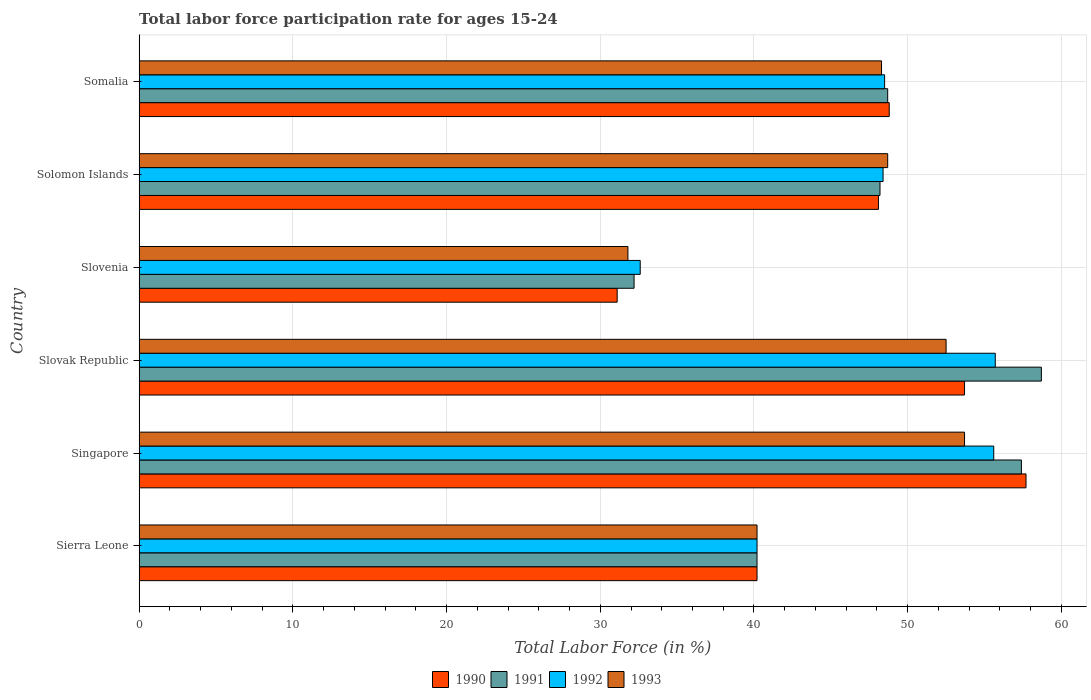How many groups of bars are there?
Your answer should be compact. 6. Are the number of bars per tick equal to the number of legend labels?
Make the answer very short. Yes. How many bars are there on the 3rd tick from the top?
Offer a very short reply. 4. What is the label of the 1st group of bars from the top?
Provide a short and direct response. Somalia. What is the labor force participation rate in 1991 in Sierra Leone?
Your answer should be very brief. 40.2. Across all countries, what is the maximum labor force participation rate in 1993?
Offer a terse response. 53.7. Across all countries, what is the minimum labor force participation rate in 1992?
Make the answer very short. 32.6. In which country was the labor force participation rate in 1991 maximum?
Offer a terse response. Slovak Republic. In which country was the labor force participation rate in 1990 minimum?
Offer a very short reply. Slovenia. What is the total labor force participation rate in 1991 in the graph?
Make the answer very short. 285.4. What is the difference between the labor force participation rate in 1991 in Slovenia and that in Somalia?
Your answer should be very brief. -16.5. What is the difference between the labor force participation rate in 1991 in Somalia and the labor force participation rate in 1990 in Solomon Islands?
Make the answer very short. 0.6. What is the average labor force participation rate in 1992 per country?
Your response must be concise. 46.83. In how many countries, is the labor force participation rate in 1993 greater than 18 %?
Ensure brevity in your answer.  6. What is the ratio of the labor force participation rate in 1991 in Sierra Leone to that in Slovak Republic?
Your answer should be compact. 0.68. Is the labor force participation rate in 1990 in Singapore less than that in Solomon Islands?
Make the answer very short. No. Is the difference between the labor force participation rate in 1992 in Singapore and Slovak Republic greater than the difference between the labor force participation rate in 1990 in Singapore and Slovak Republic?
Your response must be concise. No. What is the difference between the highest and the second highest labor force participation rate in 1993?
Your response must be concise. 1.2. What is the difference between the highest and the lowest labor force participation rate in 1993?
Give a very brief answer. 21.9. How many bars are there?
Keep it short and to the point. 24. Are all the bars in the graph horizontal?
Your answer should be very brief. Yes. How many countries are there in the graph?
Offer a very short reply. 6. Are the values on the major ticks of X-axis written in scientific E-notation?
Your response must be concise. No. Does the graph contain grids?
Offer a very short reply. Yes. How many legend labels are there?
Your answer should be very brief. 4. How are the legend labels stacked?
Your answer should be very brief. Horizontal. What is the title of the graph?
Keep it short and to the point. Total labor force participation rate for ages 15-24. What is the label or title of the X-axis?
Provide a short and direct response. Total Labor Force (in %). What is the label or title of the Y-axis?
Provide a succinct answer. Country. What is the Total Labor Force (in %) of 1990 in Sierra Leone?
Offer a very short reply. 40.2. What is the Total Labor Force (in %) in 1991 in Sierra Leone?
Provide a succinct answer. 40.2. What is the Total Labor Force (in %) in 1992 in Sierra Leone?
Make the answer very short. 40.2. What is the Total Labor Force (in %) of 1993 in Sierra Leone?
Offer a terse response. 40.2. What is the Total Labor Force (in %) in 1990 in Singapore?
Keep it short and to the point. 57.7. What is the Total Labor Force (in %) in 1991 in Singapore?
Offer a terse response. 57.4. What is the Total Labor Force (in %) in 1992 in Singapore?
Give a very brief answer. 55.6. What is the Total Labor Force (in %) in 1993 in Singapore?
Your answer should be compact. 53.7. What is the Total Labor Force (in %) in 1990 in Slovak Republic?
Offer a terse response. 53.7. What is the Total Labor Force (in %) in 1991 in Slovak Republic?
Offer a very short reply. 58.7. What is the Total Labor Force (in %) of 1992 in Slovak Republic?
Your answer should be compact. 55.7. What is the Total Labor Force (in %) in 1993 in Slovak Republic?
Ensure brevity in your answer.  52.5. What is the Total Labor Force (in %) in 1990 in Slovenia?
Your answer should be very brief. 31.1. What is the Total Labor Force (in %) of 1991 in Slovenia?
Provide a short and direct response. 32.2. What is the Total Labor Force (in %) in 1992 in Slovenia?
Your response must be concise. 32.6. What is the Total Labor Force (in %) in 1993 in Slovenia?
Provide a short and direct response. 31.8. What is the Total Labor Force (in %) of 1990 in Solomon Islands?
Keep it short and to the point. 48.1. What is the Total Labor Force (in %) in 1991 in Solomon Islands?
Your answer should be very brief. 48.2. What is the Total Labor Force (in %) of 1992 in Solomon Islands?
Your answer should be very brief. 48.4. What is the Total Labor Force (in %) in 1993 in Solomon Islands?
Ensure brevity in your answer.  48.7. What is the Total Labor Force (in %) in 1990 in Somalia?
Your response must be concise. 48.8. What is the Total Labor Force (in %) of 1991 in Somalia?
Your answer should be very brief. 48.7. What is the Total Labor Force (in %) in 1992 in Somalia?
Provide a succinct answer. 48.5. What is the Total Labor Force (in %) of 1993 in Somalia?
Your response must be concise. 48.3. Across all countries, what is the maximum Total Labor Force (in %) of 1990?
Your answer should be very brief. 57.7. Across all countries, what is the maximum Total Labor Force (in %) in 1991?
Offer a terse response. 58.7. Across all countries, what is the maximum Total Labor Force (in %) in 1992?
Your answer should be very brief. 55.7. Across all countries, what is the maximum Total Labor Force (in %) in 1993?
Offer a very short reply. 53.7. Across all countries, what is the minimum Total Labor Force (in %) of 1990?
Offer a terse response. 31.1. Across all countries, what is the minimum Total Labor Force (in %) in 1991?
Make the answer very short. 32.2. Across all countries, what is the minimum Total Labor Force (in %) of 1992?
Your answer should be very brief. 32.6. Across all countries, what is the minimum Total Labor Force (in %) in 1993?
Keep it short and to the point. 31.8. What is the total Total Labor Force (in %) in 1990 in the graph?
Provide a succinct answer. 279.6. What is the total Total Labor Force (in %) in 1991 in the graph?
Offer a terse response. 285.4. What is the total Total Labor Force (in %) in 1992 in the graph?
Offer a terse response. 281. What is the total Total Labor Force (in %) in 1993 in the graph?
Your answer should be compact. 275.2. What is the difference between the Total Labor Force (in %) of 1990 in Sierra Leone and that in Singapore?
Give a very brief answer. -17.5. What is the difference between the Total Labor Force (in %) in 1991 in Sierra Leone and that in Singapore?
Your answer should be very brief. -17.2. What is the difference between the Total Labor Force (in %) in 1992 in Sierra Leone and that in Singapore?
Your response must be concise. -15.4. What is the difference between the Total Labor Force (in %) of 1993 in Sierra Leone and that in Singapore?
Provide a short and direct response. -13.5. What is the difference between the Total Labor Force (in %) of 1991 in Sierra Leone and that in Slovak Republic?
Provide a succinct answer. -18.5. What is the difference between the Total Labor Force (in %) in 1992 in Sierra Leone and that in Slovak Republic?
Ensure brevity in your answer.  -15.5. What is the difference between the Total Labor Force (in %) in 1993 in Sierra Leone and that in Slovak Republic?
Keep it short and to the point. -12.3. What is the difference between the Total Labor Force (in %) of 1991 in Sierra Leone and that in Slovenia?
Your answer should be compact. 8. What is the difference between the Total Labor Force (in %) in 1992 in Sierra Leone and that in Slovenia?
Your response must be concise. 7.6. What is the difference between the Total Labor Force (in %) of 1993 in Sierra Leone and that in Slovenia?
Your answer should be compact. 8.4. What is the difference between the Total Labor Force (in %) of 1990 in Sierra Leone and that in Solomon Islands?
Your answer should be very brief. -7.9. What is the difference between the Total Labor Force (in %) in 1991 in Sierra Leone and that in Solomon Islands?
Ensure brevity in your answer.  -8. What is the difference between the Total Labor Force (in %) in 1993 in Sierra Leone and that in Solomon Islands?
Give a very brief answer. -8.5. What is the difference between the Total Labor Force (in %) in 1990 in Sierra Leone and that in Somalia?
Offer a very short reply. -8.6. What is the difference between the Total Labor Force (in %) in 1992 in Sierra Leone and that in Somalia?
Provide a succinct answer. -8.3. What is the difference between the Total Labor Force (in %) of 1993 in Sierra Leone and that in Somalia?
Give a very brief answer. -8.1. What is the difference between the Total Labor Force (in %) of 1990 in Singapore and that in Slovak Republic?
Keep it short and to the point. 4. What is the difference between the Total Labor Force (in %) in 1990 in Singapore and that in Slovenia?
Provide a succinct answer. 26.6. What is the difference between the Total Labor Force (in %) in 1991 in Singapore and that in Slovenia?
Keep it short and to the point. 25.2. What is the difference between the Total Labor Force (in %) in 1992 in Singapore and that in Slovenia?
Keep it short and to the point. 23. What is the difference between the Total Labor Force (in %) of 1993 in Singapore and that in Slovenia?
Your answer should be very brief. 21.9. What is the difference between the Total Labor Force (in %) of 1992 in Singapore and that in Solomon Islands?
Your answer should be compact. 7.2. What is the difference between the Total Labor Force (in %) in 1990 in Singapore and that in Somalia?
Your answer should be very brief. 8.9. What is the difference between the Total Labor Force (in %) in 1991 in Singapore and that in Somalia?
Give a very brief answer. 8.7. What is the difference between the Total Labor Force (in %) of 1993 in Singapore and that in Somalia?
Give a very brief answer. 5.4. What is the difference between the Total Labor Force (in %) of 1990 in Slovak Republic and that in Slovenia?
Provide a succinct answer. 22.6. What is the difference between the Total Labor Force (in %) of 1991 in Slovak Republic and that in Slovenia?
Provide a short and direct response. 26.5. What is the difference between the Total Labor Force (in %) in 1992 in Slovak Republic and that in Slovenia?
Your answer should be compact. 23.1. What is the difference between the Total Labor Force (in %) in 1993 in Slovak Republic and that in Slovenia?
Offer a very short reply. 20.7. What is the difference between the Total Labor Force (in %) of 1990 in Slovak Republic and that in Solomon Islands?
Keep it short and to the point. 5.6. What is the difference between the Total Labor Force (in %) in 1991 in Slovak Republic and that in Solomon Islands?
Give a very brief answer. 10.5. What is the difference between the Total Labor Force (in %) of 1990 in Slovenia and that in Solomon Islands?
Keep it short and to the point. -17. What is the difference between the Total Labor Force (in %) of 1991 in Slovenia and that in Solomon Islands?
Ensure brevity in your answer.  -16. What is the difference between the Total Labor Force (in %) in 1992 in Slovenia and that in Solomon Islands?
Your answer should be compact. -15.8. What is the difference between the Total Labor Force (in %) of 1993 in Slovenia and that in Solomon Islands?
Keep it short and to the point. -16.9. What is the difference between the Total Labor Force (in %) in 1990 in Slovenia and that in Somalia?
Make the answer very short. -17.7. What is the difference between the Total Labor Force (in %) of 1991 in Slovenia and that in Somalia?
Give a very brief answer. -16.5. What is the difference between the Total Labor Force (in %) in 1992 in Slovenia and that in Somalia?
Your answer should be compact. -15.9. What is the difference between the Total Labor Force (in %) of 1993 in Slovenia and that in Somalia?
Your response must be concise. -16.5. What is the difference between the Total Labor Force (in %) of 1992 in Solomon Islands and that in Somalia?
Your answer should be very brief. -0.1. What is the difference between the Total Labor Force (in %) in 1990 in Sierra Leone and the Total Labor Force (in %) in 1991 in Singapore?
Offer a very short reply. -17.2. What is the difference between the Total Labor Force (in %) of 1990 in Sierra Leone and the Total Labor Force (in %) of 1992 in Singapore?
Keep it short and to the point. -15.4. What is the difference between the Total Labor Force (in %) of 1991 in Sierra Leone and the Total Labor Force (in %) of 1992 in Singapore?
Make the answer very short. -15.4. What is the difference between the Total Labor Force (in %) of 1992 in Sierra Leone and the Total Labor Force (in %) of 1993 in Singapore?
Your answer should be very brief. -13.5. What is the difference between the Total Labor Force (in %) in 1990 in Sierra Leone and the Total Labor Force (in %) in 1991 in Slovak Republic?
Provide a short and direct response. -18.5. What is the difference between the Total Labor Force (in %) in 1990 in Sierra Leone and the Total Labor Force (in %) in 1992 in Slovak Republic?
Your answer should be compact. -15.5. What is the difference between the Total Labor Force (in %) in 1991 in Sierra Leone and the Total Labor Force (in %) in 1992 in Slovak Republic?
Make the answer very short. -15.5. What is the difference between the Total Labor Force (in %) in 1990 in Sierra Leone and the Total Labor Force (in %) in 1991 in Slovenia?
Offer a very short reply. 8. What is the difference between the Total Labor Force (in %) in 1990 in Sierra Leone and the Total Labor Force (in %) in 1991 in Solomon Islands?
Provide a succinct answer. -8. What is the difference between the Total Labor Force (in %) in 1991 in Sierra Leone and the Total Labor Force (in %) in 1992 in Somalia?
Ensure brevity in your answer.  -8.3. What is the difference between the Total Labor Force (in %) in 1990 in Singapore and the Total Labor Force (in %) in 1992 in Slovak Republic?
Your answer should be compact. 2. What is the difference between the Total Labor Force (in %) of 1991 in Singapore and the Total Labor Force (in %) of 1993 in Slovak Republic?
Give a very brief answer. 4.9. What is the difference between the Total Labor Force (in %) of 1992 in Singapore and the Total Labor Force (in %) of 1993 in Slovak Republic?
Your answer should be compact. 3.1. What is the difference between the Total Labor Force (in %) of 1990 in Singapore and the Total Labor Force (in %) of 1991 in Slovenia?
Your response must be concise. 25.5. What is the difference between the Total Labor Force (in %) in 1990 in Singapore and the Total Labor Force (in %) in 1992 in Slovenia?
Provide a succinct answer. 25.1. What is the difference between the Total Labor Force (in %) of 1990 in Singapore and the Total Labor Force (in %) of 1993 in Slovenia?
Keep it short and to the point. 25.9. What is the difference between the Total Labor Force (in %) in 1991 in Singapore and the Total Labor Force (in %) in 1992 in Slovenia?
Make the answer very short. 24.8. What is the difference between the Total Labor Force (in %) of 1991 in Singapore and the Total Labor Force (in %) of 1993 in Slovenia?
Your response must be concise. 25.6. What is the difference between the Total Labor Force (in %) of 1992 in Singapore and the Total Labor Force (in %) of 1993 in Slovenia?
Give a very brief answer. 23.8. What is the difference between the Total Labor Force (in %) of 1990 in Singapore and the Total Labor Force (in %) of 1991 in Solomon Islands?
Keep it short and to the point. 9.5. What is the difference between the Total Labor Force (in %) in 1990 in Singapore and the Total Labor Force (in %) in 1993 in Solomon Islands?
Your answer should be very brief. 9. What is the difference between the Total Labor Force (in %) in 1991 in Singapore and the Total Labor Force (in %) in 1992 in Solomon Islands?
Provide a succinct answer. 9. What is the difference between the Total Labor Force (in %) of 1990 in Singapore and the Total Labor Force (in %) of 1991 in Somalia?
Provide a short and direct response. 9. What is the difference between the Total Labor Force (in %) of 1992 in Singapore and the Total Labor Force (in %) of 1993 in Somalia?
Make the answer very short. 7.3. What is the difference between the Total Labor Force (in %) of 1990 in Slovak Republic and the Total Labor Force (in %) of 1991 in Slovenia?
Ensure brevity in your answer.  21.5. What is the difference between the Total Labor Force (in %) of 1990 in Slovak Republic and the Total Labor Force (in %) of 1992 in Slovenia?
Your response must be concise. 21.1. What is the difference between the Total Labor Force (in %) of 1990 in Slovak Republic and the Total Labor Force (in %) of 1993 in Slovenia?
Keep it short and to the point. 21.9. What is the difference between the Total Labor Force (in %) in 1991 in Slovak Republic and the Total Labor Force (in %) in 1992 in Slovenia?
Your answer should be compact. 26.1. What is the difference between the Total Labor Force (in %) in 1991 in Slovak Republic and the Total Labor Force (in %) in 1993 in Slovenia?
Offer a very short reply. 26.9. What is the difference between the Total Labor Force (in %) in 1992 in Slovak Republic and the Total Labor Force (in %) in 1993 in Slovenia?
Give a very brief answer. 23.9. What is the difference between the Total Labor Force (in %) of 1991 in Slovak Republic and the Total Labor Force (in %) of 1993 in Solomon Islands?
Your answer should be compact. 10. What is the difference between the Total Labor Force (in %) in 1992 in Slovak Republic and the Total Labor Force (in %) in 1993 in Solomon Islands?
Ensure brevity in your answer.  7. What is the difference between the Total Labor Force (in %) in 1990 in Slovak Republic and the Total Labor Force (in %) in 1992 in Somalia?
Your answer should be compact. 5.2. What is the difference between the Total Labor Force (in %) of 1990 in Slovak Republic and the Total Labor Force (in %) of 1993 in Somalia?
Your answer should be very brief. 5.4. What is the difference between the Total Labor Force (in %) in 1991 in Slovak Republic and the Total Labor Force (in %) in 1993 in Somalia?
Ensure brevity in your answer.  10.4. What is the difference between the Total Labor Force (in %) of 1990 in Slovenia and the Total Labor Force (in %) of 1991 in Solomon Islands?
Provide a short and direct response. -17.1. What is the difference between the Total Labor Force (in %) of 1990 in Slovenia and the Total Labor Force (in %) of 1992 in Solomon Islands?
Keep it short and to the point. -17.3. What is the difference between the Total Labor Force (in %) in 1990 in Slovenia and the Total Labor Force (in %) in 1993 in Solomon Islands?
Your response must be concise. -17.6. What is the difference between the Total Labor Force (in %) of 1991 in Slovenia and the Total Labor Force (in %) of 1992 in Solomon Islands?
Make the answer very short. -16.2. What is the difference between the Total Labor Force (in %) in 1991 in Slovenia and the Total Labor Force (in %) in 1993 in Solomon Islands?
Make the answer very short. -16.5. What is the difference between the Total Labor Force (in %) of 1992 in Slovenia and the Total Labor Force (in %) of 1993 in Solomon Islands?
Give a very brief answer. -16.1. What is the difference between the Total Labor Force (in %) in 1990 in Slovenia and the Total Labor Force (in %) in 1991 in Somalia?
Your answer should be compact. -17.6. What is the difference between the Total Labor Force (in %) in 1990 in Slovenia and the Total Labor Force (in %) in 1992 in Somalia?
Provide a short and direct response. -17.4. What is the difference between the Total Labor Force (in %) of 1990 in Slovenia and the Total Labor Force (in %) of 1993 in Somalia?
Give a very brief answer. -17.2. What is the difference between the Total Labor Force (in %) in 1991 in Slovenia and the Total Labor Force (in %) in 1992 in Somalia?
Keep it short and to the point. -16.3. What is the difference between the Total Labor Force (in %) of 1991 in Slovenia and the Total Labor Force (in %) of 1993 in Somalia?
Your answer should be very brief. -16.1. What is the difference between the Total Labor Force (in %) in 1992 in Slovenia and the Total Labor Force (in %) in 1993 in Somalia?
Offer a very short reply. -15.7. What is the difference between the Total Labor Force (in %) of 1990 in Solomon Islands and the Total Labor Force (in %) of 1991 in Somalia?
Give a very brief answer. -0.6. What is the difference between the Total Labor Force (in %) in 1990 in Solomon Islands and the Total Labor Force (in %) in 1992 in Somalia?
Your answer should be compact. -0.4. What is the difference between the Total Labor Force (in %) of 1990 in Solomon Islands and the Total Labor Force (in %) of 1993 in Somalia?
Offer a terse response. -0.2. What is the difference between the Total Labor Force (in %) of 1991 in Solomon Islands and the Total Labor Force (in %) of 1992 in Somalia?
Make the answer very short. -0.3. What is the difference between the Total Labor Force (in %) in 1991 in Solomon Islands and the Total Labor Force (in %) in 1993 in Somalia?
Provide a short and direct response. -0.1. What is the difference between the Total Labor Force (in %) of 1992 in Solomon Islands and the Total Labor Force (in %) of 1993 in Somalia?
Make the answer very short. 0.1. What is the average Total Labor Force (in %) in 1990 per country?
Your answer should be compact. 46.6. What is the average Total Labor Force (in %) of 1991 per country?
Make the answer very short. 47.57. What is the average Total Labor Force (in %) of 1992 per country?
Make the answer very short. 46.83. What is the average Total Labor Force (in %) in 1993 per country?
Give a very brief answer. 45.87. What is the difference between the Total Labor Force (in %) in 1990 and Total Labor Force (in %) in 1991 in Sierra Leone?
Ensure brevity in your answer.  0. What is the difference between the Total Labor Force (in %) in 1991 and Total Labor Force (in %) in 1992 in Sierra Leone?
Your answer should be very brief. 0. What is the difference between the Total Labor Force (in %) of 1991 and Total Labor Force (in %) of 1993 in Sierra Leone?
Your answer should be very brief. 0. What is the difference between the Total Labor Force (in %) in 1990 and Total Labor Force (in %) in 1991 in Singapore?
Keep it short and to the point. 0.3. What is the difference between the Total Labor Force (in %) in 1990 and Total Labor Force (in %) in 1992 in Singapore?
Ensure brevity in your answer.  2.1. What is the difference between the Total Labor Force (in %) of 1990 and Total Labor Force (in %) of 1993 in Singapore?
Offer a very short reply. 4. What is the difference between the Total Labor Force (in %) of 1991 and Total Labor Force (in %) of 1992 in Singapore?
Your answer should be compact. 1.8. What is the difference between the Total Labor Force (in %) of 1991 and Total Labor Force (in %) of 1993 in Singapore?
Offer a terse response. 3.7. What is the difference between the Total Labor Force (in %) of 1990 and Total Labor Force (in %) of 1991 in Slovak Republic?
Your answer should be compact. -5. What is the difference between the Total Labor Force (in %) of 1991 and Total Labor Force (in %) of 1993 in Slovak Republic?
Offer a very short reply. 6.2. What is the difference between the Total Labor Force (in %) of 1990 and Total Labor Force (in %) of 1991 in Slovenia?
Give a very brief answer. -1.1. What is the difference between the Total Labor Force (in %) in 1990 and Total Labor Force (in %) in 1992 in Slovenia?
Your answer should be compact. -1.5. What is the difference between the Total Labor Force (in %) of 1991 and Total Labor Force (in %) of 1993 in Slovenia?
Give a very brief answer. 0.4. What is the difference between the Total Labor Force (in %) of 1990 and Total Labor Force (in %) of 1993 in Solomon Islands?
Provide a succinct answer. -0.6. What is the difference between the Total Labor Force (in %) of 1991 and Total Labor Force (in %) of 1992 in Solomon Islands?
Make the answer very short. -0.2. What is the difference between the Total Labor Force (in %) of 1992 and Total Labor Force (in %) of 1993 in Solomon Islands?
Ensure brevity in your answer.  -0.3. What is the difference between the Total Labor Force (in %) of 1990 and Total Labor Force (in %) of 1992 in Somalia?
Provide a succinct answer. 0.3. What is the difference between the Total Labor Force (in %) of 1990 and Total Labor Force (in %) of 1993 in Somalia?
Make the answer very short. 0.5. What is the difference between the Total Labor Force (in %) of 1992 and Total Labor Force (in %) of 1993 in Somalia?
Give a very brief answer. 0.2. What is the ratio of the Total Labor Force (in %) in 1990 in Sierra Leone to that in Singapore?
Your answer should be very brief. 0.7. What is the ratio of the Total Labor Force (in %) of 1991 in Sierra Leone to that in Singapore?
Your answer should be very brief. 0.7. What is the ratio of the Total Labor Force (in %) of 1992 in Sierra Leone to that in Singapore?
Make the answer very short. 0.72. What is the ratio of the Total Labor Force (in %) in 1993 in Sierra Leone to that in Singapore?
Offer a very short reply. 0.75. What is the ratio of the Total Labor Force (in %) in 1990 in Sierra Leone to that in Slovak Republic?
Provide a short and direct response. 0.75. What is the ratio of the Total Labor Force (in %) in 1991 in Sierra Leone to that in Slovak Republic?
Keep it short and to the point. 0.68. What is the ratio of the Total Labor Force (in %) of 1992 in Sierra Leone to that in Slovak Republic?
Give a very brief answer. 0.72. What is the ratio of the Total Labor Force (in %) of 1993 in Sierra Leone to that in Slovak Republic?
Give a very brief answer. 0.77. What is the ratio of the Total Labor Force (in %) in 1990 in Sierra Leone to that in Slovenia?
Your answer should be very brief. 1.29. What is the ratio of the Total Labor Force (in %) in 1991 in Sierra Leone to that in Slovenia?
Your answer should be very brief. 1.25. What is the ratio of the Total Labor Force (in %) of 1992 in Sierra Leone to that in Slovenia?
Your response must be concise. 1.23. What is the ratio of the Total Labor Force (in %) in 1993 in Sierra Leone to that in Slovenia?
Provide a short and direct response. 1.26. What is the ratio of the Total Labor Force (in %) of 1990 in Sierra Leone to that in Solomon Islands?
Give a very brief answer. 0.84. What is the ratio of the Total Labor Force (in %) in 1991 in Sierra Leone to that in Solomon Islands?
Your answer should be compact. 0.83. What is the ratio of the Total Labor Force (in %) in 1992 in Sierra Leone to that in Solomon Islands?
Offer a very short reply. 0.83. What is the ratio of the Total Labor Force (in %) in 1993 in Sierra Leone to that in Solomon Islands?
Provide a short and direct response. 0.83. What is the ratio of the Total Labor Force (in %) of 1990 in Sierra Leone to that in Somalia?
Keep it short and to the point. 0.82. What is the ratio of the Total Labor Force (in %) in 1991 in Sierra Leone to that in Somalia?
Make the answer very short. 0.83. What is the ratio of the Total Labor Force (in %) in 1992 in Sierra Leone to that in Somalia?
Make the answer very short. 0.83. What is the ratio of the Total Labor Force (in %) of 1993 in Sierra Leone to that in Somalia?
Keep it short and to the point. 0.83. What is the ratio of the Total Labor Force (in %) in 1990 in Singapore to that in Slovak Republic?
Make the answer very short. 1.07. What is the ratio of the Total Labor Force (in %) of 1991 in Singapore to that in Slovak Republic?
Give a very brief answer. 0.98. What is the ratio of the Total Labor Force (in %) of 1992 in Singapore to that in Slovak Republic?
Offer a terse response. 1. What is the ratio of the Total Labor Force (in %) of 1993 in Singapore to that in Slovak Republic?
Your response must be concise. 1.02. What is the ratio of the Total Labor Force (in %) in 1990 in Singapore to that in Slovenia?
Offer a very short reply. 1.86. What is the ratio of the Total Labor Force (in %) in 1991 in Singapore to that in Slovenia?
Offer a very short reply. 1.78. What is the ratio of the Total Labor Force (in %) in 1992 in Singapore to that in Slovenia?
Offer a terse response. 1.71. What is the ratio of the Total Labor Force (in %) of 1993 in Singapore to that in Slovenia?
Your answer should be compact. 1.69. What is the ratio of the Total Labor Force (in %) in 1990 in Singapore to that in Solomon Islands?
Provide a short and direct response. 1.2. What is the ratio of the Total Labor Force (in %) of 1991 in Singapore to that in Solomon Islands?
Ensure brevity in your answer.  1.19. What is the ratio of the Total Labor Force (in %) in 1992 in Singapore to that in Solomon Islands?
Your response must be concise. 1.15. What is the ratio of the Total Labor Force (in %) in 1993 in Singapore to that in Solomon Islands?
Provide a short and direct response. 1.1. What is the ratio of the Total Labor Force (in %) of 1990 in Singapore to that in Somalia?
Your answer should be compact. 1.18. What is the ratio of the Total Labor Force (in %) in 1991 in Singapore to that in Somalia?
Ensure brevity in your answer.  1.18. What is the ratio of the Total Labor Force (in %) of 1992 in Singapore to that in Somalia?
Ensure brevity in your answer.  1.15. What is the ratio of the Total Labor Force (in %) of 1993 in Singapore to that in Somalia?
Make the answer very short. 1.11. What is the ratio of the Total Labor Force (in %) in 1990 in Slovak Republic to that in Slovenia?
Give a very brief answer. 1.73. What is the ratio of the Total Labor Force (in %) in 1991 in Slovak Republic to that in Slovenia?
Keep it short and to the point. 1.82. What is the ratio of the Total Labor Force (in %) in 1992 in Slovak Republic to that in Slovenia?
Make the answer very short. 1.71. What is the ratio of the Total Labor Force (in %) in 1993 in Slovak Republic to that in Slovenia?
Your answer should be compact. 1.65. What is the ratio of the Total Labor Force (in %) in 1990 in Slovak Republic to that in Solomon Islands?
Your response must be concise. 1.12. What is the ratio of the Total Labor Force (in %) in 1991 in Slovak Republic to that in Solomon Islands?
Ensure brevity in your answer.  1.22. What is the ratio of the Total Labor Force (in %) in 1992 in Slovak Republic to that in Solomon Islands?
Give a very brief answer. 1.15. What is the ratio of the Total Labor Force (in %) of 1993 in Slovak Republic to that in Solomon Islands?
Ensure brevity in your answer.  1.08. What is the ratio of the Total Labor Force (in %) in 1990 in Slovak Republic to that in Somalia?
Your answer should be very brief. 1.1. What is the ratio of the Total Labor Force (in %) of 1991 in Slovak Republic to that in Somalia?
Keep it short and to the point. 1.21. What is the ratio of the Total Labor Force (in %) in 1992 in Slovak Republic to that in Somalia?
Ensure brevity in your answer.  1.15. What is the ratio of the Total Labor Force (in %) in 1993 in Slovak Republic to that in Somalia?
Your answer should be compact. 1.09. What is the ratio of the Total Labor Force (in %) of 1990 in Slovenia to that in Solomon Islands?
Your answer should be very brief. 0.65. What is the ratio of the Total Labor Force (in %) of 1991 in Slovenia to that in Solomon Islands?
Keep it short and to the point. 0.67. What is the ratio of the Total Labor Force (in %) of 1992 in Slovenia to that in Solomon Islands?
Your answer should be compact. 0.67. What is the ratio of the Total Labor Force (in %) in 1993 in Slovenia to that in Solomon Islands?
Give a very brief answer. 0.65. What is the ratio of the Total Labor Force (in %) of 1990 in Slovenia to that in Somalia?
Keep it short and to the point. 0.64. What is the ratio of the Total Labor Force (in %) in 1991 in Slovenia to that in Somalia?
Your answer should be very brief. 0.66. What is the ratio of the Total Labor Force (in %) of 1992 in Slovenia to that in Somalia?
Offer a terse response. 0.67. What is the ratio of the Total Labor Force (in %) of 1993 in Slovenia to that in Somalia?
Keep it short and to the point. 0.66. What is the ratio of the Total Labor Force (in %) in 1990 in Solomon Islands to that in Somalia?
Your answer should be compact. 0.99. What is the ratio of the Total Labor Force (in %) in 1991 in Solomon Islands to that in Somalia?
Ensure brevity in your answer.  0.99. What is the ratio of the Total Labor Force (in %) in 1993 in Solomon Islands to that in Somalia?
Make the answer very short. 1.01. What is the difference between the highest and the second highest Total Labor Force (in %) in 1991?
Provide a short and direct response. 1.3. What is the difference between the highest and the second highest Total Labor Force (in %) of 1992?
Provide a succinct answer. 0.1. What is the difference between the highest and the lowest Total Labor Force (in %) in 1990?
Give a very brief answer. 26.6. What is the difference between the highest and the lowest Total Labor Force (in %) of 1992?
Keep it short and to the point. 23.1. What is the difference between the highest and the lowest Total Labor Force (in %) of 1993?
Keep it short and to the point. 21.9. 